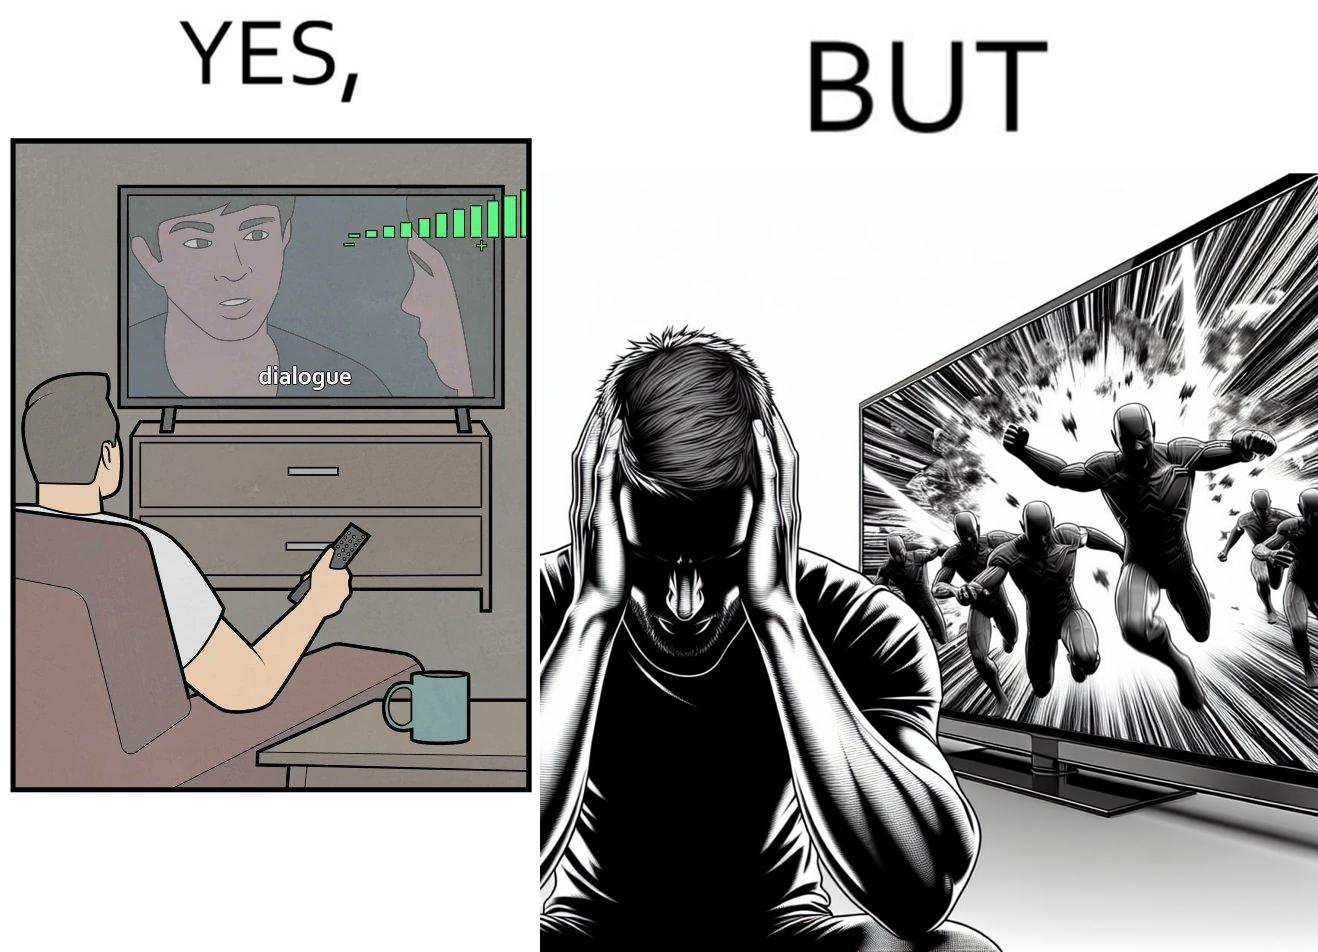Describe what you see in this image. The action scenes of the movies or TV programs are mostly low in sound and people aren't able to hear them properly but in the action scenes due to the background music and other noise the sound becomes unbearable to some peoples 